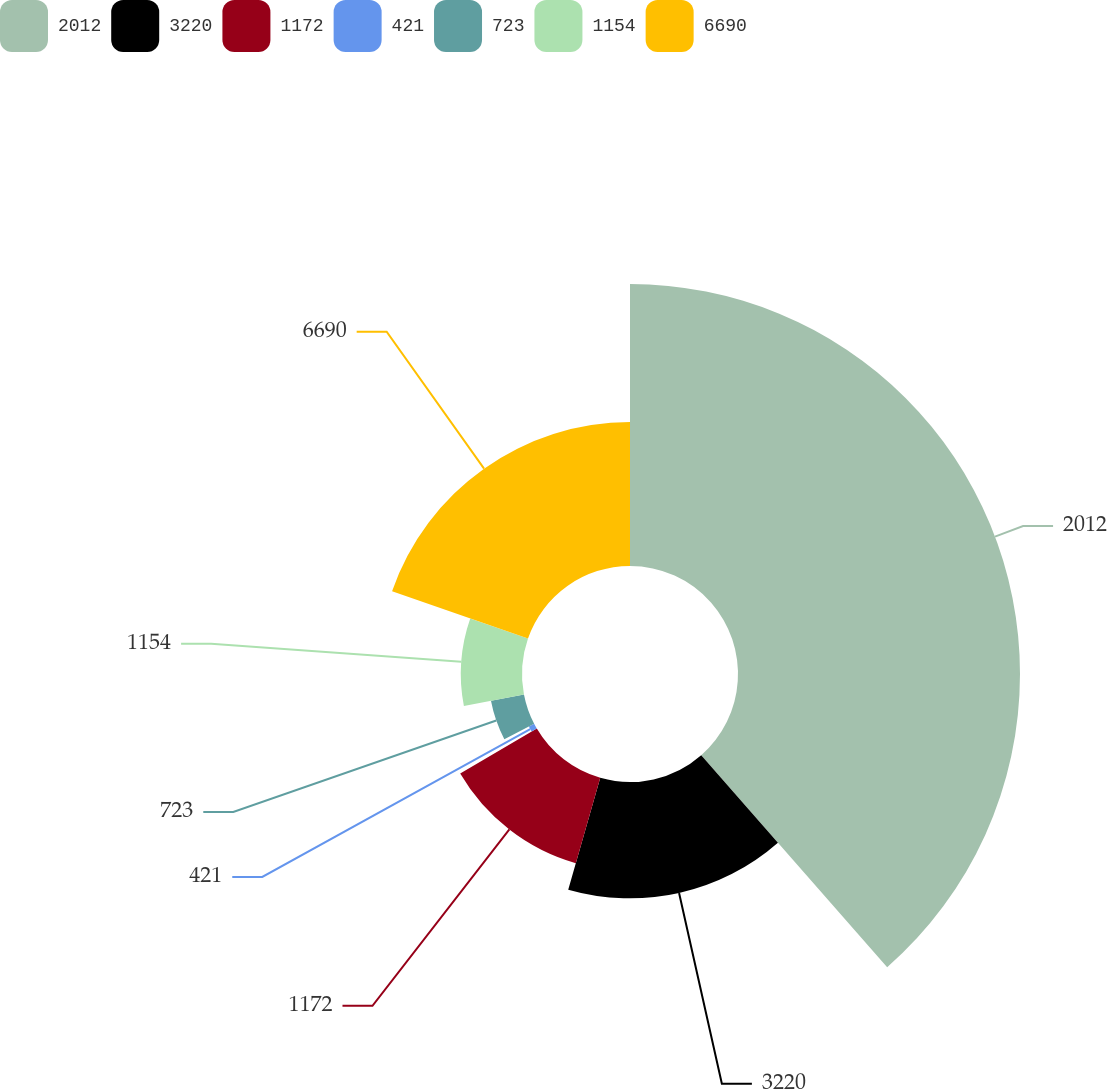Convert chart. <chart><loc_0><loc_0><loc_500><loc_500><pie_chart><fcel>2012<fcel>3220<fcel>1172<fcel>421<fcel>723<fcel>1154<fcel>6690<nl><fcel>38.54%<fcel>15.9%<fcel>12.13%<fcel>0.81%<fcel>4.59%<fcel>8.36%<fcel>19.67%<nl></chart> 